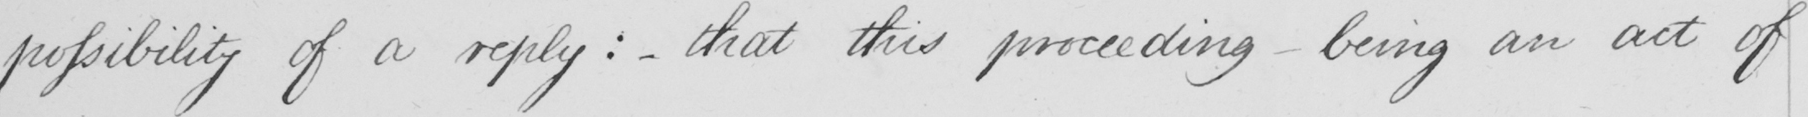Can you tell me what this handwritten text says? possibility of a reply :   _  that this proceeding being an act of 